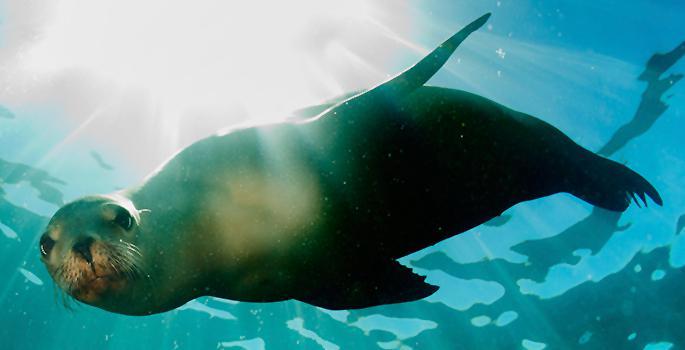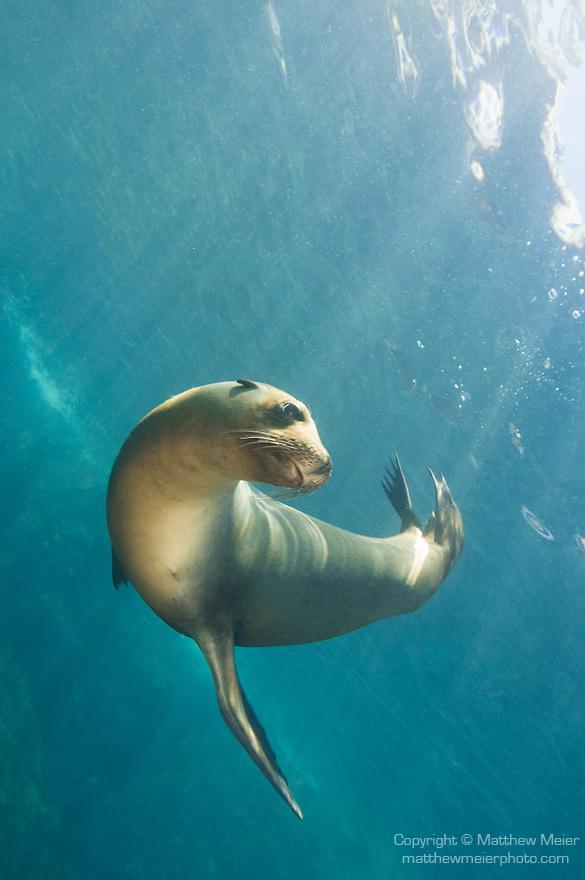The first image is the image on the left, the second image is the image on the right. For the images displayed, is the sentence "We have two seals here, swimming." factually correct? Answer yes or no. Yes. The first image is the image on the left, the second image is the image on the right. Analyze the images presented: Is the assertion "there are two animals total" valid? Answer yes or no. Yes. 